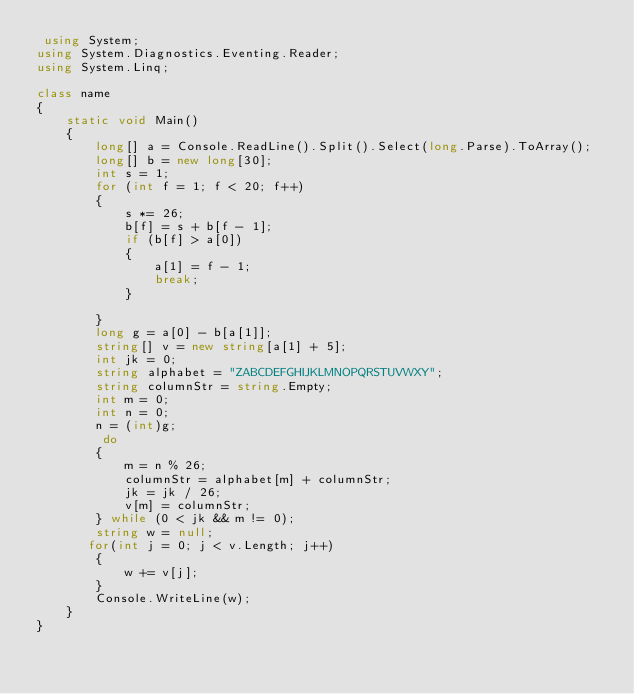Convert code to text. <code><loc_0><loc_0><loc_500><loc_500><_C#_> using System;
using System.Diagnostics.Eventing.Reader;
using System.Linq;

class name
{
    static void Main()
    {
        long[] a = Console.ReadLine().Split().Select(long.Parse).ToArray();
        long[] b = new long[30];
        int s = 1;
        for (int f = 1; f < 20; f++)
        {
            s *= 26;
            b[f] = s + b[f - 1];
            if (b[f] > a[0])
            {
                a[1] = f - 1;
                break;
            }

        }
        long g = a[0] - b[a[1]];
        string[] v = new string[a[1] + 5];
        int jk = 0;
        string alphabet = "ZABCDEFGHIJKLMNOPQRSTUVWXY";
        string columnStr = string.Empty;
        int m = 0;
        int n = 0;
        n = (int)g;
         do
        {
            m = n % 26;
            columnStr = alphabet[m] + columnStr;
            jk = jk / 26;
            v[m] = columnStr;
        } while (0 < jk && m != 0);
        string w = null;
       for(int j = 0; j < v.Length; j++)
        {
            w += v[j];
        }
        Console.WriteLine(w);
    }
}

</code> 